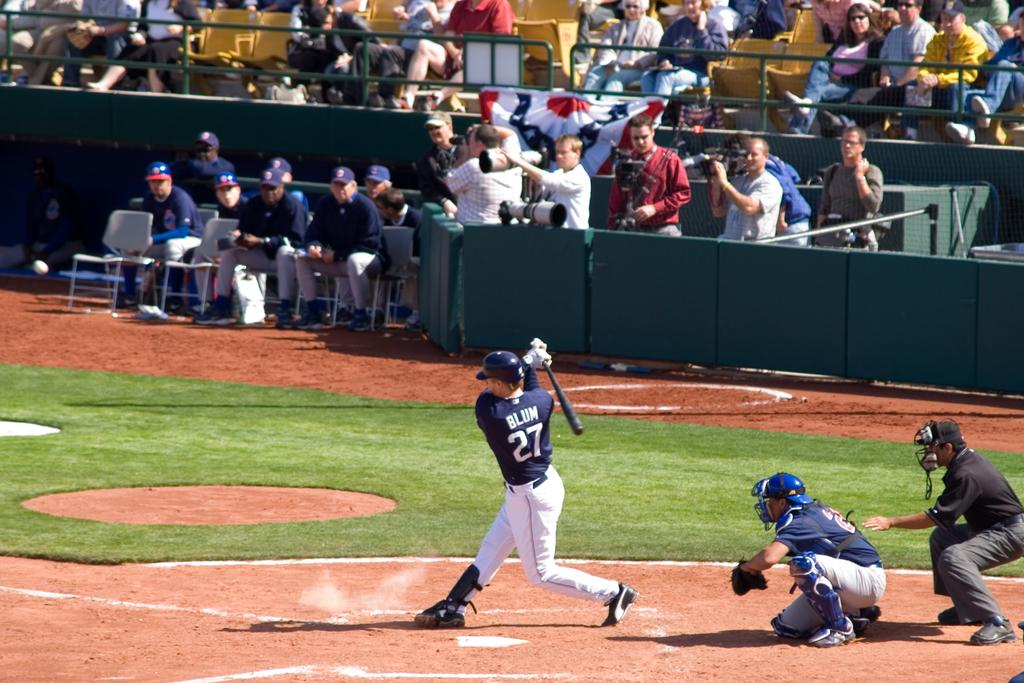<image>
Summarize the visual content of the image. The baseball player who's currently swinging the bart has the last name of Blum 